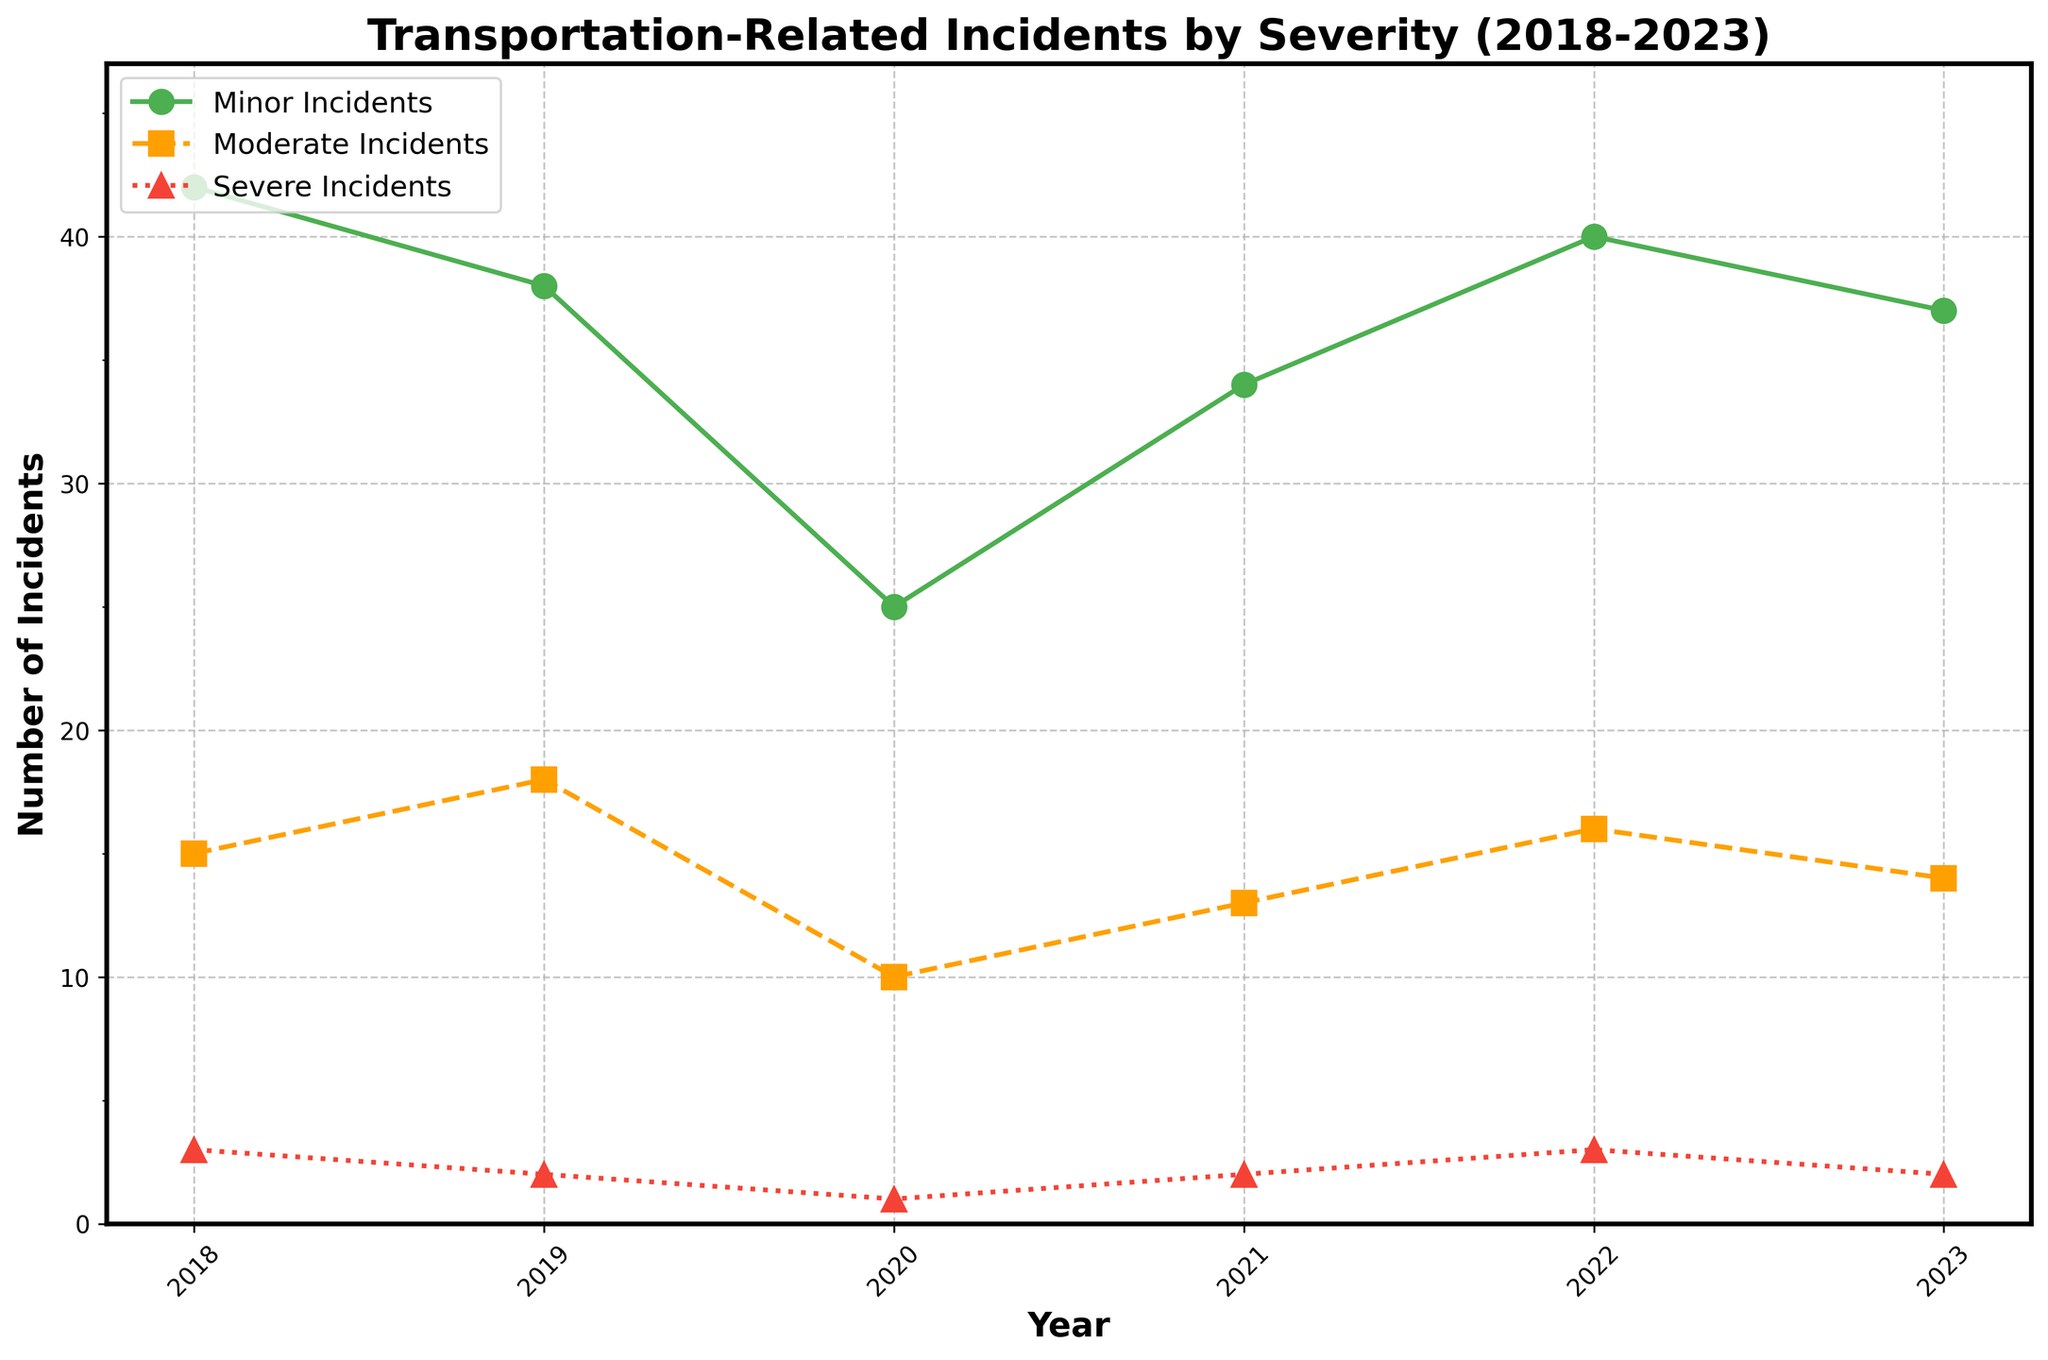What year had the highest number of minor incidents? Look at the data plotted for minor incidents over the years. The highest peak in the 'Minor Incidents' line corresponds to 2018.
Answer: 2018 Compare the number of moderate incidents between 2019 and 2022. Which year had more? Look at the 'Moderate Incidents' line plotted on the chart. In 2019, there were 18 moderate incidents and in 2022, there were 16.
Answer: 2019 How many severe incidents were reported in total from 2018 to 2023? Add the values of severe incidents for all years: 3 (2018) + 2 (2019) + 1 (2020) + 2 (2021) + 3 (2022) + 2 (2023).
Answer: 13 Did the number of minor incidents increase or decrease from 2020 to 2021? Look at the 'Minor Incidents' line between 2020 and 2021. In 2020, there were 25 minor incidents, and in 2021, there were 34. There is an increase.
Answer: Increase What is the average number of moderate incidents from 2018 to 2023? Sum the values of moderate incidents over the years and divide by the number of years: (15 + 18 + 10 + 13 + 16 + 14) / 6.
Answer: 14.33 Between 2021 and 2023, which year had the lowest number of minor incidents? Look at the 'Minor Incidents' line between 2021 and 2023. In 2023, there were 37 incidents, compared to 34 in 2021 and 40 in 2022.
Answer: 2021 Which type of incidents shows the most stability in numbers over the years? Comparing the fluctuations in the 'Minor', 'Moderate', and 'Severe Incidents' lines, the 'Severe Incidents' line shows the least variation.
Answer: Severe By how much did the number of severe incidents change from 2018 to 2020? Compare the 'Severe Incidents' numbers from 2018 to 2020. In 2018, there were 3 incidents, and in 2020, there was 1, showing a decrease of 2.
Answer: Decrease by 2 Are there more minor incidents or moderate incidents in 2023? Look at the 'Minor Incidents' and 'Moderate Incidents' lines for 2023. There are 37 minor incidents compared to 14 moderate incidents.
Answer: Minor incidents What is the trend in the number of severe incidents over the years shown? Look at the 'Severe Incidents' line across the years. The numbers fluctuate minimally, with low values each year. There is a general stability.
Answer: Stable 